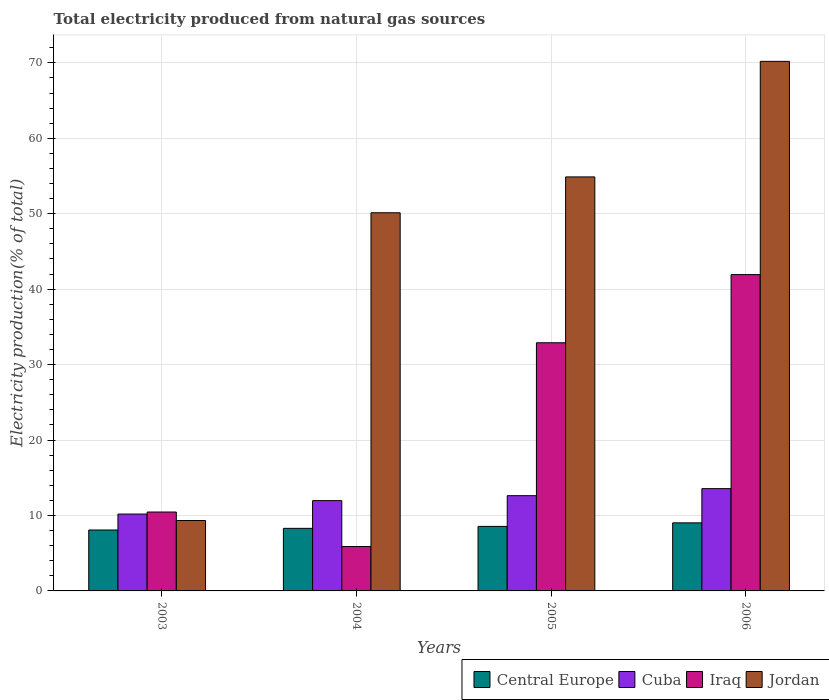How many different coloured bars are there?
Give a very brief answer. 4. What is the label of the 4th group of bars from the left?
Provide a short and direct response. 2006. What is the total electricity produced in Iraq in 2006?
Provide a succinct answer. 41.93. Across all years, what is the maximum total electricity produced in Cuba?
Ensure brevity in your answer.  13.56. Across all years, what is the minimum total electricity produced in Jordan?
Provide a short and direct response. 9.33. In which year was the total electricity produced in Central Europe minimum?
Keep it short and to the point. 2003. What is the total total electricity produced in Iraq in the graph?
Keep it short and to the point. 91.17. What is the difference between the total electricity produced in Central Europe in 2004 and that in 2006?
Give a very brief answer. -0.73. What is the difference between the total electricity produced in Central Europe in 2003 and the total electricity produced in Cuba in 2006?
Your answer should be very brief. -5.48. What is the average total electricity produced in Jordan per year?
Make the answer very short. 46.13. In the year 2004, what is the difference between the total electricity produced in Iraq and total electricity produced in Central Europe?
Offer a very short reply. -2.41. What is the ratio of the total electricity produced in Cuba in 2004 to that in 2005?
Make the answer very short. 0.95. Is the total electricity produced in Iraq in 2004 less than that in 2005?
Make the answer very short. Yes. What is the difference between the highest and the second highest total electricity produced in Cuba?
Offer a terse response. 0.93. What is the difference between the highest and the lowest total electricity produced in Iraq?
Offer a very short reply. 36.05. In how many years, is the total electricity produced in Central Europe greater than the average total electricity produced in Central Europe taken over all years?
Offer a terse response. 2. What does the 2nd bar from the left in 2006 represents?
Provide a short and direct response. Cuba. What does the 2nd bar from the right in 2003 represents?
Your response must be concise. Iraq. How many bars are there?
Provide a short and direct response. 16. Are the values on the major ticks of Y-axis written in scientific E-notation?
Keep it short and to the point. No. Does the graph contain any zero values?
Provide a succinct answer. No. How are the legend labels stacked?
Provide a short and direct response. Horizontal. What is the title of the graph?
Give a very brief answer. Total electricity produced from natural gas sources. Does "Iran" appear as one of the legend labels in the graph?
Keep it short and to the point. No. What is the Electricity production(% of total) of Central Europe in 2003?
Provide a succinct answer. 8.08. What is the Electricity production(% of total) of Cuba in 2003?
Your answer should be very brief. 10.19. What is the Electricity production(% of total) of Iraq in 2003?
Offer a very short reply. 10.46. What is the Electricity production(% of total) of Jordan in 2003?
Offer a terse response. 9.33. What is the Electricity production(% of total) of Central Europe in 2004?
Offer a very short reply. 8.29. What is the Electricity production(% of total) in Cuba in 2004?
Your response must be concise. 11.97. What is the Electricity production(% of total) in Iraq in 2004?
Provide a short and direct response. 5.88. What is the Electricity production(% of total) in Jordan in 2004?
Provide a succinct answer. 50.13. What is the Electricity production(% of total) of Central Europe in 2005?
Make the answer very short. 8.55. What is the Electricity production(% of total) of Cuba in 2005?
Offer a very short reply. 12.63. What is the Electricity production(% of total) of Iraq in 2005?
Give a very brief answer. 32.89. What is the Electricity production(% of total) of Jordan in 2005?
Give a very brief answer. 54.88. What is the Electricity production(% of total) of Central Europe in 2006?
Your answer should be compact. 9.02. What is the Electricity production(% of total) in Cuba in 2006?
Give a very brief answer. 13.56. What is the Electricity production(% of total) in Iraq in 2006?
Provide a succinct answer. 41.93. What is the Electricity production(% of total) of Jordan in 2006?
Your response must be concise. 70.2. Across all years, what is the maximum Electricity production(% of total) of Central Europe?
Ensure brevity in your answer.  9.02. Across all years, what is the maximum Electricity production(% of total) of Cuba?
Make the answer very short. 13.56. Across all years, what is the maximum Electricity production(% of total) of Iraq?
Your answer should be very brief. 41.93. Across all years, what is the maximum Electricity production(% of total) of Jordan?
Keep it short and to the point. 70.2. Across all years, what is the minimum Electricity production(% of total) in Central Europe?
Make the answer very short. 8.08. Across all years, what is the minimum Electricity production(% of total) in Cuba?
Your answer should be very brief. 10.19. Across all years, what is the minimum Electricity production(% of total) of Iraq?
Make the answer very short. 5.88. Across all years, what is the minimum Electricity production(% of total) of Jordan?
Offer a terse response. 9.33. What is the total Electricity production(% of total) of Central Europe in the graph?
Your response must be concise. 33.95. What is the total Electricity production(% of total) of Cuba in the graph?
Offer a terse response. 48.34. What is the total Electricity production(% of total) of Iraq in the graph?
Provide a succinct answer. 91.17. What is the total Electricity production(% of total) of Jordan in the graph?
Provide a succinct answer. 184.54. What is the difference between the Electricity production(% of total) in Central Europe in 2003 and that in 2004?
Give a very brief answer. -0.22. What is the difference between the Electricity production(% of total) in Cuba in 2003 and that in 2004?
Keep it short and to the point. -1.78. What is the difference between the Electricity production(% of total) in Iraq in 2003 and that in 2004?
Make the answer very short. 4.58. What is the difference between the Electricity production(% of total) of Jordan in 2003 and that in 2004?
Ensure brevity in your answer.  -40.8. What is the difference between the Electricity production(% of total) in Central Europe in 2003 and that in 2005?
Provide a short and direct response. -0.48. What is the difference between the Electricity production(% of total) of Cuba in 2003 and that in 2005?
Make the answer very short. -2.44. What is the difference between the Electricity production(% of total) of Iraq in 2003 and that in 2005?
Offer a very short reply. -22.44. What is the difference between the Electricity production(% of total) in Jordan in 2003 and that in 2005?
Ensure brevity in your answer.  -45.55. What is the difference between the Electricity production(% of total) in Central Europe in 2003 and that in 2006?
Ensure brevity in your answer.  -0.95. What is the difference between the Electricity production(% of total) in Cuba in 2003 and that in 2006?
Offer a very short reply. -3.37. What is the difference between the Electricity production(% of total) of Iraq in 2003 and that in 2006?
Your response must be concise. -31.47. What is the difference between the Electricity production(% of total) of Jordan in 2003 and that in 2006?
Make the answer very short. -60.87. What is the difference between the Electricity production(% of total) in Central Europe in 2004 and that in 2005?
Provide a succinct answer. -0.26. What is the difference between the Electricity production(% of total) of Cuba in 2004 and that in 2005?
Your answer should be compact. -0.66. What is the difference between the Electricity production(% of total) in Iraq in 2004 and that in 2005?
Give a very brief answer. -27.01. What is the difference between the Electricity production(% of total) in Jordan in 2004 and that in 2005?
Provide a succinct answer. -4.75. What is the difference between the Electricity production(% of total) in Central Europe in 2004 and that in 2006?
Offer a very short reply. -0.73. What is the difference between the Electricity production(% of total) of Cuba in 2004 and that in 2006?
Your answer should be very brief. -1.59. What is the difference between the Electricity production(% of total) of Iraq in 2004 and that in 2006?
Your answer should be compact. -36.05. What is the difference between the Electricity production(% of total) in Jordan in 2004 and that in 2006?
Make the answer very short. -20.07. What is the difference between the Electricity production(% of total) in Central Europe in 2005 and that in 2006?
Offer a very short reply. -0.47. What is the difference between the Electricity production(% of total) in Cuba in 2005 and that in 2006?
Your answer should be compact. -0.93. What is the difference between the Electricity production(% of total) in Iraq in 2005 and that in 2006?
Provide a short and direct response. -9.04. What is the difference between the Electricity production(% of total) in Jordan in 2005 and that in 2006?
Your answer should be compact. -15.32. What is the difference between the Electricity production(% of total) of Central Europe in 2003 and the Electricity production(% of total) of Cuba in 2004?
Provide a short and direct response. -3.89. What is the difference between the Electricity production(% of total) of Central Europe in 2003 and the Electricity production(% of total) of Iraq in 2004?
Make the answer very short. 2.19. What is the difference between the Electricity production(% of total) in Central Europe in 2003 and the Electricity production(% of total) in Jordan in 2004?
Offer a terse response. -42.05. What is the difference between the Electricity production(% of total) of Cuba in 2003 and the Electricity production(% of total) of Iraq in 2004?
Your answer should be compact. 4.31. What is the difference between the Electricity production(% of total) of Cuba in 2003 and the Electricity production(% of total) of Jordan in 2004?
Ensure brevity in your answer.  -39.94. What is the difference between the Electricity production(% of total) of Iraq in 2003 and the Electricity production(% of total) of Jordan in 2004?
Your answer should be compact. -39.67. What is the difference between the Electricity production(% of total) of Central Europe in 2003 and the Electricity production(% of total) of Cuba in 2005?
Your answer should be compact. -4.55. What is the difference between the Electricity production(% of total) of Central Europe in 2003 and the Electricity production(% of total) of Iraq in 2005?
Your answer should be very brief. -24.82. What is the difference between the Electricity production(% of total) of Central Europe in 2003 and the Electricity production(% of total) of Jordan in 2005?
Provide a succinct answer. -46.8. What is the difference between the Electricity production(% of total) of Cuba in 2003 and the Electricity production(% of total) of Iraq in 2005?
Provide a short and direct response. -22.7. What is the difference between the Electricity production(% of total) of Cuba in 2003 and the Electricity production(% of total) of Jordan in 2005?
Your answer should be very brief. -44.69. What is the difference between the Electricity production(% of total) of Iraq in 2003 and the Electricity production(% of total) of Jordan in 2005?
Offer a very short reply. -44.42. What is the difference between the Electricity production(% of total) of Central Europe in 2003 and the Electricity production(% of total) of Cuba in 2006?
Provide a short and direct response. -5.48. What is the difference between the Electricity production(% of total) of Central Europe in 2003 and the Electricity production(% of total) of Iraq in 2006?
Your answer should be compact. -33.85. What is the difference between the Electricity production(% of total) of Central Europe in 2003 and the Electricity production(% of total) of Jordan in 2006?
Ensure brevity in your answer.  -62.12. What is the difference between the Electricity production(% of total) of Cuba in 2003 and the Electricity production(% of total) of Iraq in 2006?
Keep it short and to the point. -31.74. What is the difference between the Electricity production(% of total) of Cuba in 2003 and the Electricity production(% of total) of Jordan in 2006?
Keep it short and to the point. -60.01. What is the difference between the Electricity production(% of total) in Iraq in 2003 and the Electricity production(% of total) in Jordan in 2006?
Make the answer very short. -59.74. What is the difference between the Electricity production(% of total) in Central Europe in 2004 and the Electricity production(% of total) in Cuba in 2005?
Your answer should be very brief. -4.33. What is the difference between the Electricity production(% of total) in Central Europe in 2004 and the Electricity production(% of total) in Iraq in 2005?
Your answer should be very brief. -24.6. What is the difference between the Electricity production(% of total) in Central Europe in 2004 and the Electricity production(% of total) in Jordan in 2005?
Keep it short and to the point. -46.58. What is the difference between the Electricity production(% of total) in Cuba in 2004 and the Electricity production(% of total) in Iraq in 2005?
Provide a short and direct response. -20.93. What is the difference between the Electricity production(% of total) of Cuba in 2004 and the Electricity production(% of total) of Jordan in 2005?
Your response must be concise. -42.91. What is the difference between the Electricity production(% of total) in Iraq in 2004 and the Electricity production(% of total) in Jordan in 2005?
Give a very brief answer. -49. What is the difference between the Electricity production(% of total) in Central Europe in 2004 and the Electricity production(% of total) in Cuba in 2006?
Make the answer very short. -5.26. What is the difference between the Electricity production(% of total) of Central Europe in 2004 and the Electricity production(% of total) of Iraq in 2006?
Ensure brevity in your answer.  -33.64. What is the difference between the Electricity production(% of total) of Central Europe in 2004 and the Electricity production(% of total) of Jordan in 2006?
Provide a short and direct response. -61.9. What is the difference between the Electricity production(% of total) of Cuba in 2004 and the Electricity production(% of total) of Iraq in 2006?
Your response must be concise. -29.96. What is the difference between the Electricity production(% of total) in Cuba in 2004 and the Electricity production(% of total) in Jordan in 2006?
Offer a very short reply. -58.23. What is the difference between the Electricity production(% of total) in Iraq in 2004 and the Electricity production(% of total) in Jordan in 2006?
Ensure brevity in your answer.  -64.31. What is the difference between the Electricity production(% of total) in Central Europe in 2005 and the Electricity production(% of total) in Cuba in 2006?
Ensure brevity in your answer.  -5.01. What is the difference between the Electricity production(% of total) of Central Europe in 2005 and the Electricity production(% of total) of Iraq in 2006?
Your response must be concise. -33.38. What is the difference between the Electricity production(% of total) in Central Europe in 2005 and the Electricity production(% of total) in Jordan in 2006?
Offer a terse response. -61.64. What is the difference between the Electricity production(% of total) in Cuba in 2005 and the Electricity production(% of total) in Iraq in 2006?
Your answer should be compact. -29.3. What is the difference between the Electricity production(% of total) in Cuba in 2005 and the Electricity production(% of total) in Jordan in 2006?
Make the answer very short. -57.57. What is the difference between the Electricity production(% of total) of Iraq in 2005 and the Electricity production(% of total) of Jordan in 2006?
Offer a very short reply. -37.3. What is the average Electricity production(% of total) in Central Europe per year?
Make the answer very short. 8.49. What is the average Electricity production(% of total) of Cuba per year?
Your answer should be very brief. 12.09. What is the average Electricity production(% of total) in Iraq per year?
Ensure brevity in your answer.  22.79. What is the average Electricity production(% of total) in Jordan per year?
Keep it short and to the point. 46.13. In the year 2003, what is the difference between the Electricity production(% of total) of Central Europe and Electricity production(% of total) of Cuba?
Your response must be concise. -2.11. In the year 2003, what is the difference between the Electricity production(% of total) in Central Europe and Electricity production(% of total) in Iraq?
Your response must be concise. -2.38. In the year 2003, what is the difference between the Electricity production(% of total) of Central Europe and Electricity production(% of total) of Jordan?
Your answer should be very brief. -1.26. In the year 2003, what is the difference between the Electricity production(% of total) in Cuba and Electricity production(% of total) in Iraq?
Offer a terse response. -0.27. In the year 2003, what is the difference between the Electricity production(% of total) of Cuba and Electricity production(% of total) of Jordan?
Provide a short and direct response. 0.86. In the year 2003, what is the difference between the Electricity production(% of total) of Iraq and Electricity production(% of total) of Jordan?
Keep it short and to the point. 1.13. In the year 2004, what is the difference between the Electricity production(% of total) in Central Europe and Electricity production(% of total) in Cuba?
Your answer should be compact. -3.67. In the year 2004, what is the difference between the Electricity production(% of total) of Central Europe and Electricity production(% of total) of Iraq?
Provide a succinct answer. 2.41. In the year 2004, what is the difference between the Electricity production(% of total) of Central Europe and Electricity production(% of total) of Jordan?
Your response must be concise. -41.83. In the year 2004, what is the difference between the Electricity production(% of total) of Cuba and Electricity production(% of total) of Iraq?
Give a very brief answer. 6.08. In the year 2004, what is the difference between the Electricity production(% of total) of Cuba and Electricity production(% of total) of Jordan?
Ensure brevity in your answer.  -38.16. In the year 2004, what is the difference between the Electricity production(% of total) in Iraq and Electricity production(% of total) in Jordan?
Give a very brief answer. -44.24. In the year 2005, what is the difference between the Electricity production(% of total) of Central Europe and Electricity production(% of total) of Cuba?
Your answer should be compact. -4.07. In the year 2005, what is the difference between the Electricity production(% of total) of Central Europe and Electricity production(% of total) of Iraq?
Give a very brief answer. -24.34. In the year 2005, what is the difference between the Electricity production(% of total) of Central Europe and Electricity production(% of total) of Jordan?
Keep it short and to the point. -46.33. In the year 2005, what is the difference between the Electricity production(% of total) in Cuba and Electricity production(% of total) in Iraq?
Your answer should be compact. -20.27. In the year 2005, what is the difference between the Electricity production(% of total) of Cuba and Electricity production(% of total) of Jordan?
Offer a very short reply. -42.25. In the year 2005, what is the difference between the Electricity production(% of total) of Iraq and Electricity production(% of total) of Jordan?
Your answer should be compact. -21.98. In the year 2006, what is the difference between the Electricity production(% of total) of Central Europe and Electricity production(% of total) of Cuba?
Make the answer very short. -4.54. In the year 2006, what is the difference between the Electricity production(% of total) of Central Europe and Electricity production(% of total) of Iraq?
Your answer should be compact. -32.91. In the year 2006, what is the difference between the Electricity production(% of total) in Central Europe and Electricity production(% of total) in Jordan?
Give a very brief answer. -61.17. In the year 2006, what is the difference between the Electricity production(% of total) in Cuba and Electricity production(% of total) in Iraq?
Ensure brevity in your answer.  -28.37. In the year 2006, what is the difference between the Electricity production(% of total) in Cuba and Electricity production(% of total) in Jordan?
Provide a succinct answer. -56.64. In the year 2006, what is the difference between the Electricity production(% of total) of Iraq and Electricity production(% of total) of Jordan?
Keep it short and to the point. -28.27. What is the ratio of the Electricity production(% of total) in Central Europe in 2003 to that in 2004?
Give a very brief answer. 0.97. What is the ratio of the Electricity production(% of total) in Cuba in 2003 to that in 2004?
Keep it short and to the point. 0.85. What is the ratio of the Electricity production(% of total) of Iraq in 2003 to that in 2004?
Your answer should be very brief. 1.78. What is the ratio of the Electricity production(% of total) in Jordan in 2003 to that in 2004?
Keep it short and to the point. 0.19. What is the ratio of the Electricity production(% of total) in Central Europe in 2003 to that in 2005?
Provide a short and direct response. 0.94. What is the ratio of the Electricity production(% of total) of Cuba in 2003 to that in 2005?
Provide a succinct answer. 0.81. What is the ratio of the Electricity production(% of total) in Iraq in 2003 to that in 2005?
Ensure brevity in your answer.  0.32. What is the ratio of the Electricity production(% of total) in Jordan in 2003 to that in 2005?
Provide a succinct answer. 0.17. What is the ratio of the Electricity production(% of total) in Central Europe in 2003 to that in 2006?
Ensure brevity in your answer.  0.9. What is the ratio of the Electricity production(% of total) in Cuba in 2003 to that in 2006?
Make the answer very short. 0.75. What is the ratio of the Electricity production(% of total) in Iraq in 2003 to that in 2006?
Provide a short and direct response. 0.25. What is the ratio of the Electricity production(% of total) of Jordan in 2003 to that in 2006?
Your answer should be compact. 0.13. What is the ratio of the Electricity production(% of total) of Central Europe in 2004 to that in 2005?
Offer a terse response. 0.97. What is the ratio of the Electricity production(% of total) in Cuba in 2004 to that in 2005?
Provide a short and direct response. 0.95. What is the ratio of the Electricity production(% of total) in Iraq in 2004 to that in 2005?
Your answer should be compact. 0.18. What is the ratio of the Electricity production(% of total) of Jordan in 2004 to that in 2005?
Your answer should be very brief. 0.91. What is the ratio of the Electricity production(% of total) in Central Europe in 2004 to that in 2006?
Give a very brief answer. 0.92. What is the ratio of the Electricity production(% of total) of Cuba in 2004 to that in 2006?
Provide a short and direct response. 0.88. What is the ratio of the Electricity production(% of total) in Iraq in 2004 to that in 2006?
Keep it short and to the point. 0.14. What is the ratio of the Electricity production(% of total) in Jordan in 2004 to that in 2006?
Offer a terse response. 0.71. What is the ratio of the Electricity production(% of total) in Central Europe in 2005 to that in 2006?
Your answer should be very brief. 0.95. What is the ratio of the Electricity production(% of total) of Cuba in 2005 to that in 2006?
Make the answer very short. 0.93. What is the ratio of the Electricity production(% of total) in Iraq in 2005 to that in 2006?
Your answer should be compact. 0.78. What is the ratio of the Electricity production(% of total) in Jordan in 2005 to that in 2006?
Give a very brief answer. 0.78. What is the difference between the highest and the second highest Electricity production(% of total) of Central Europe?
Offer a terse response. 0.47. What is the difference between the highest and the second highest Electricity production(% of total) in Cuba?
Ensure brevity in your answer.  0.93. What is the difference between the highest and the second highest Electricity production(% of total) in Iraq?
Your answer should be compact. 9.04. What is the difference between the highest and the second highest Electricity production(% of total) in Jordan?
Provide a short and direct response. 15.32. What is the difference between the highest and the lowest Electricity production(% of total) in Central Europe?
Your answer should be compact. 0.95. What is the difference between the highest and the lowest Electricity production(% of total) of Cuba?
Keep it short and to the point. 3.37. What is the difference between the highest and the lowest Electricity production(% of total) in Iraq?
Your answer should be compact. 36.05. What is the difference between the highest and the lowest Electricity production(% of total) in Jordan?
Keep it short and to the point. 60.87. 